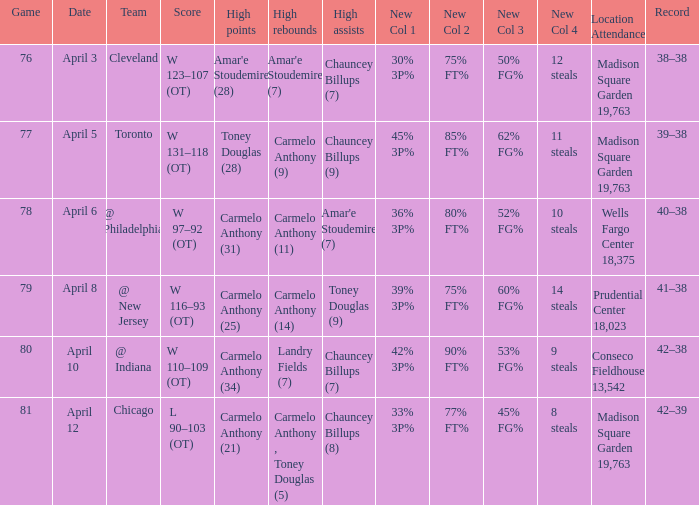Could you parse the entire table as a dict? {'header': ['Game', 'Date', 'Team', 'Score', 'High points', 'High rebounds', 'High assists', 'New Col 1', 'New Col 2', 'New Col 3', 'New Col 4', 'Location Attendance', 'Record'], 'rows': [['76', 'April 3', 'Cleveland', 'W 123–107 (OT)', "Amar'e Stoudemire (28)", "Amar'e Stoudemire (7)", 'Chauncey Billups (7)', '30% 3P%', '75% FT%', '50% FG%', '12 steals', 'Madison Square Garden 19,763', '38–38'], ['77', 'April 5', 'Toronto', 'W 131–118 (OT)', 'Toney Douglas (28)', 'Carmelo Anthony (9)', 'Chauncey Billups (9)', '45% 3P%', '85% FT%', '62% FG%', '11 steals', 'Madison Square Garden 19,763', '39–38'], ['78', 'April 6', '@ Philadelphia', 'W 97–92 (OT)', 'Carmelo Anthony (31)', 'Carmelo Anthony (11)', "Amar'e Stoudemire (7)", '36% 3P%', '80% FT%', '52% FG%', '10 steals', 'Wells Fargo Center 18,375', '40–38'], ['79', 'April 8', '@ New Jersey', 'W 116–93 (OT)', 'Carmelo Anthony (25)', 'Carmelo Anthony (14)', 'Toney Douglas (9)', '39% 3P%', '75% FT%', '60% FG%', '14 steals', 'Prudential Center 18,023', '41–38'], ['80', 'April 10', '@ Indiana', 'W 110–109 (OT)', 'Carmelo Anthony (34)', 'Landry Fields (7)', 'Chauncey Billups (7)', '42% 3P%', '90% FT%', '53% FG%', '9 steals', 'Conseco Fieldhouse 13,542', '42–38'], ['81', 'April 12', 'Chicago', 'L 90–103 (OT)', 'Carmelo Anthony (21)', 'Carmelo Anthony , Toney Douglas (5)', 'Chauncey Billups (8)', '33% 3P%', '77% FT%', '45% FG%', '8 steals', 'Madison Square Garden 19,763', '42–39']]} Name the high assists for madison square garden 19,763 and record is 39–38 Chauncey Billups (9). 